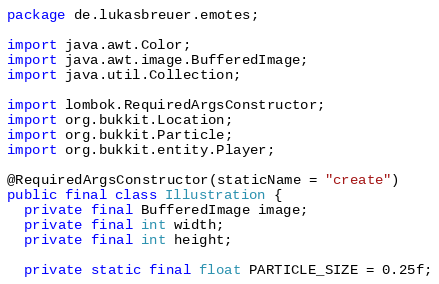Convert code to text. <code><loc_0><loc_0><loc_500><loc_500><_Java_>package de.lukasbreuer.emotes;

import java.awt.Color;
import java.awt.image.BufferedImage;
import java.util.Collection;

import lombok.RequiredArgsConstructor;
import org.bukkit.Location;
import org.bukkit.Particle;
import org.bukkit.entity.Player;

@RequiredArgsConstructor(staticName = "create")
public final class Illustration {
  private final BufferedImage image;
  private final int width;
  private final int height;

  private static final float PARTICLE_SIZE = 0.25f;</code> 